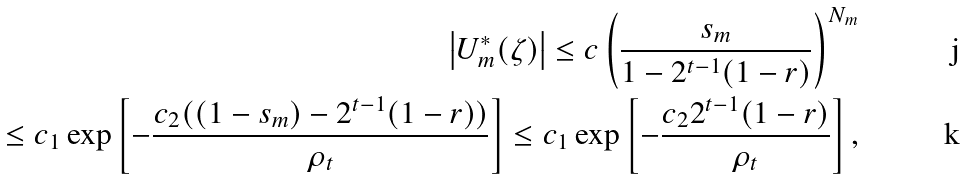<formula> <loc_0><loc_0><loc_500><loc_500>\left | U ^ { * } _ { m } ( \zeta ) \right | \leq c \left ( \frac { s _ { m } } { 1 - 2 ^ { t - 1 } ( 1 - r ) } \right ) ^ { N _ { m } } \\ \leq c _ { 1 } \exp \left [ - \frac { c _ { 2 } ( ( 1 - s _ { m } ) - 2 ^ { t - 1 } ( 1 - r ) ) } { \rho _ { t } } \right ] \leq c _ { 1 } \exp \left [ - \frac { c _ { 2 } 2 ^ { t - 1 } ( 1 - r ) } { \rho _ { t } } \right ] ,</formula> 